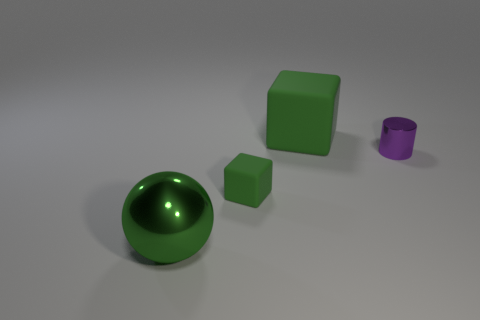Add 4 purple metal spheres. How many objects exist? 8 Subtract all balls. How many objects are left? 3 Subtract all balls. Subtract all large green metallic balls. How many objects are left? 2 Add 2 large green matte cubes. How many large green matte cubes are left? 3 Add 4 small purple metal cylinders. How many small purple metal cylinders exist? 5 Subtract 2 green cubes. How many objects are left? 2 